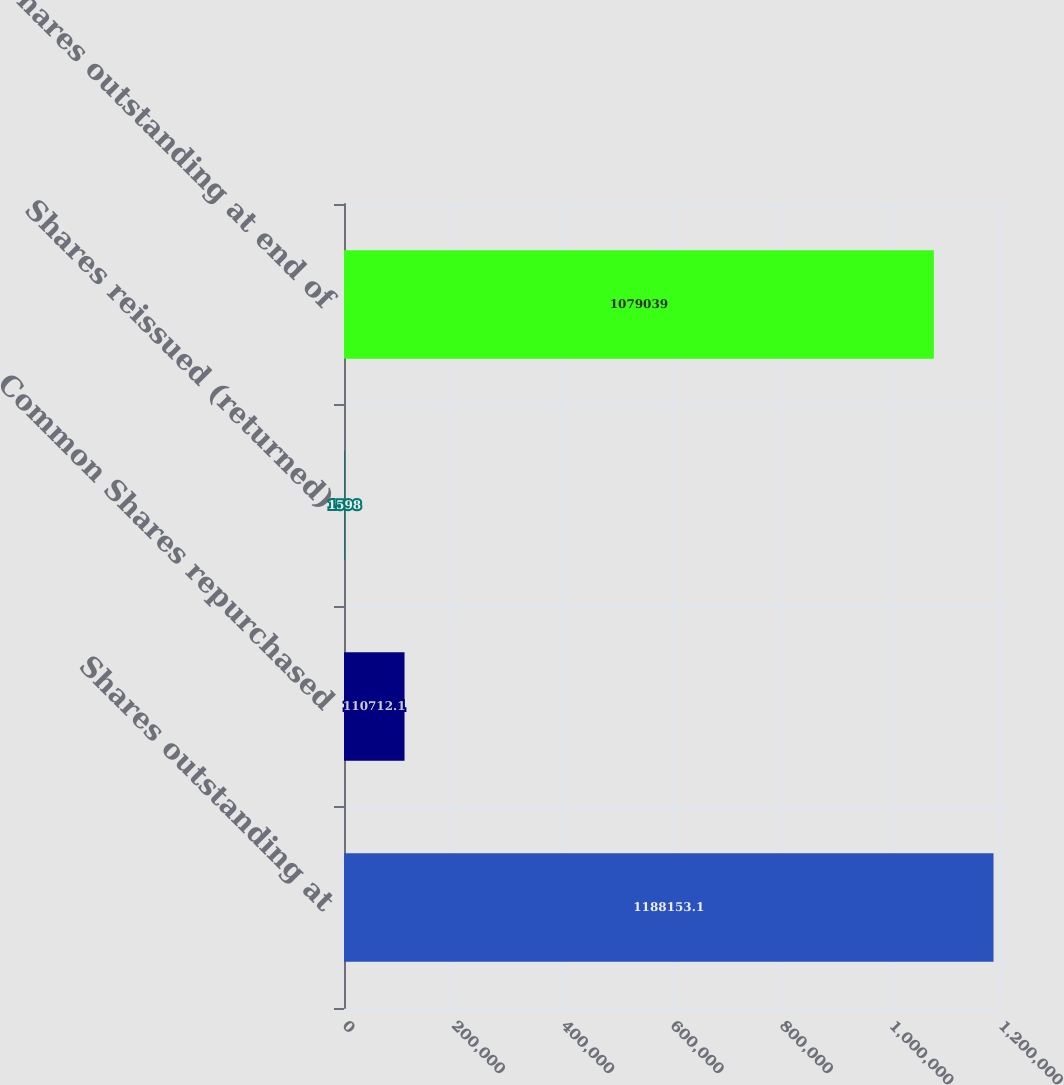Convert chart to OTSL. <chart><loc_0><loc_0><loc_500><loc_500><bar_chart><fcel>Shares outstanding at<fcel>Common Shares repurchased<fcel>Shares reissued (returned)<fcel>Shares outstanding at end of<nl><fcel>1.18815e+06<fcel>110712<fcel>1598<fcel>1.07904e+06<nl></chart> 